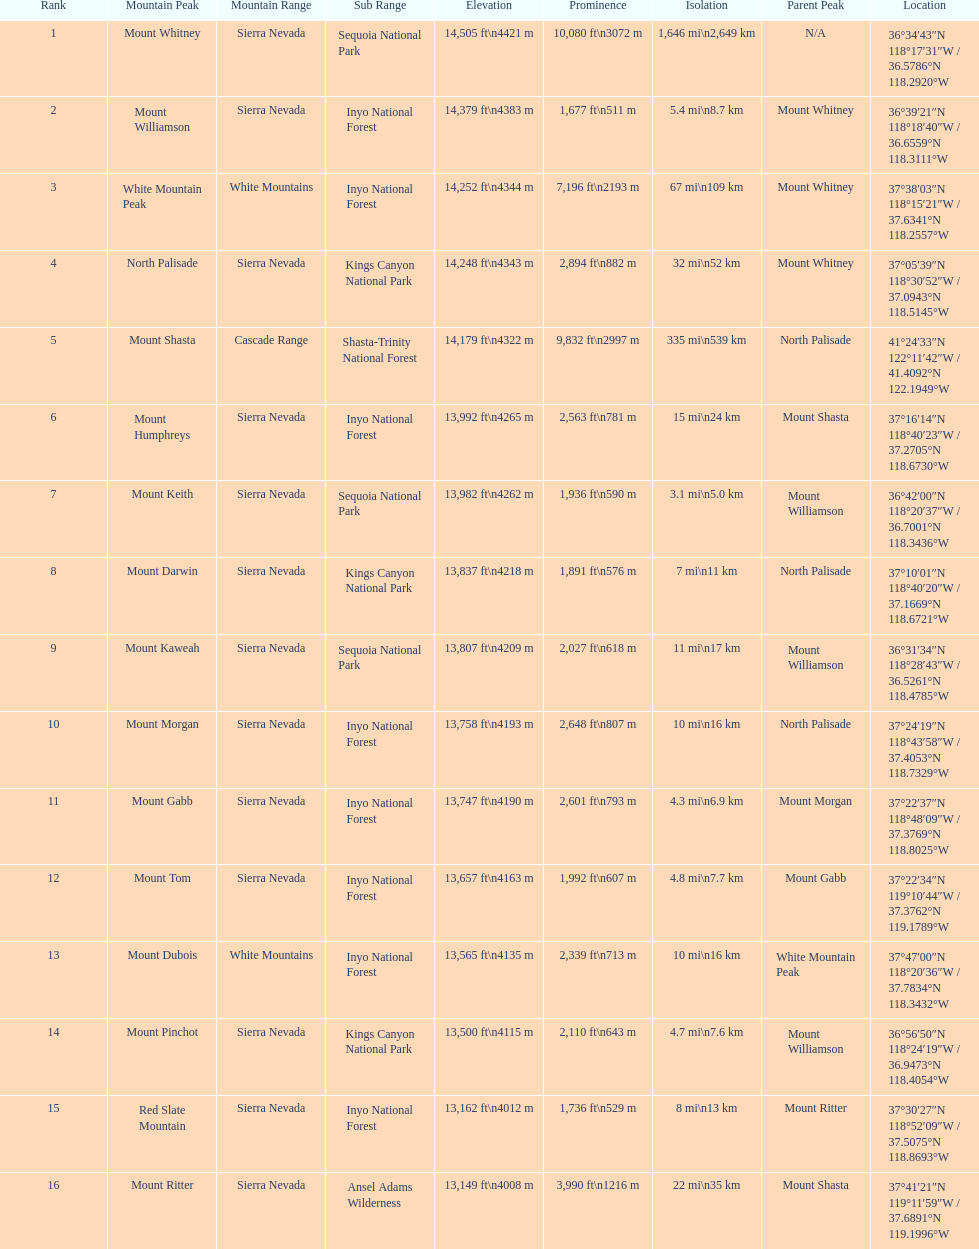Which mountain peak is no higher than 13,149 ft? Mount Ritter. 